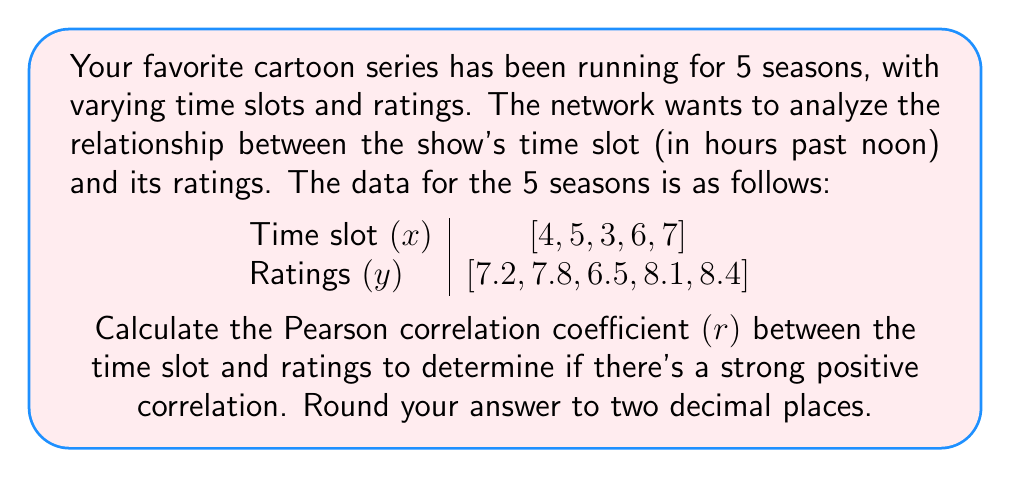What is the answer to this math problem? To calculate the Pearson correlation coefficient (r), we'll follow these steps:

1. Calculate the means of x and y:
   $\bar{x} = \frac{4 + 5 + 3 + 6 + 7}{5} = 5$
   $\bar{y} = \frac{7.2 + 7.8 + 6.5 + 8.1 + 8.4}{5} = 7.6$

2. Calculate the differences from the means:
   x - $\bar{x}$: [-1, 0, -2, 1, 2]
   y - $\bar{y}$: [-0.4, 0.2, -1.1, 0.5, 0.8]

3. Calculate the products of the differences:
   (x - $\bar{x}$)(y - $\bar{y}$): [0.4, 0, 2.2, 0.5, 1.6]

4. Calculate the squared differences:
   $(x - \bar{x})^2$: [1, 0, 4, 1, 4]
   $(y - \bar{y})^2$: [0.16, 0.04, 1.21, 0.25, 0.64]

5. Sum up the products and squared differences:
   $\sum (x - \bar{x})(y - \bar{y}) = 4.7$
   $\sum (x - \bar{x})^2 = 10$
   $\sum (y - \bar{y})^2 = 2.3$

6. Apply the Pearson correlation coefficient formula:

   $$r = \frac{\sum (x - \bar{x})(y - \bar{y})}{\sqrt{\sum (x - \bar{x})^2 \sum (y - \bar{y})^2}}$$

   $$r = \frac{4.7}{\sqrt{10 \times 2.3}} = \frac{4.7}{\sqrt{23}} = \frac{4.7}{4.7958} \approx 0.98$$

7. Round to two decimal places: 0.98
Answer: 0.98 